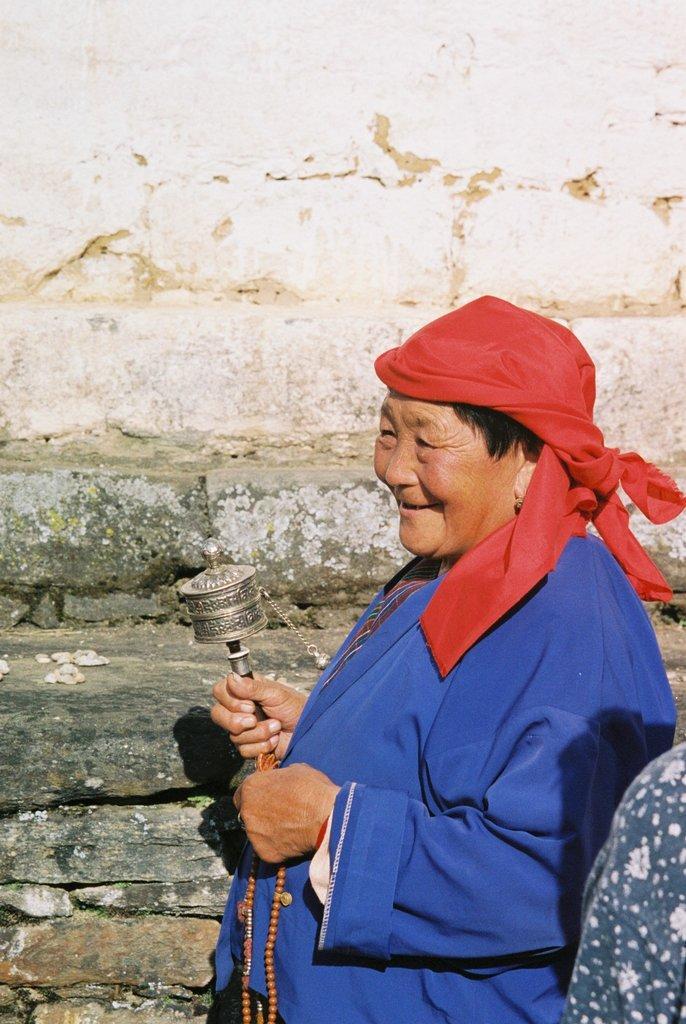Can you describe this image briefly? In the center of the image there is a woman. In the background there is wall. 